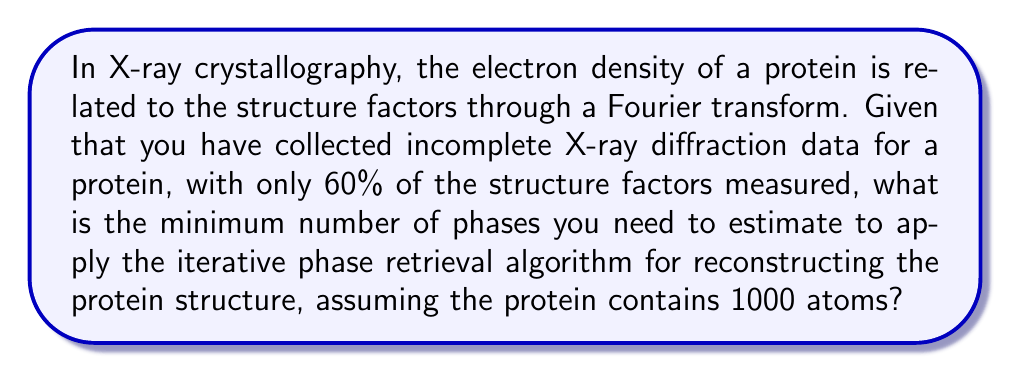Could you help me with this problem? To solve this problem, we need to follow these steps:

1. Understand the relationship between structure factors and electron density:
   The electron density $\rho(x,y,z)$ is related to the structure factors $F(h,k,l)$ through a Fourier transform:

   $$\rho(x,y,z) = \frac{1}{V} \sum_{h,k,l} F(h,k,l) e^{-2\pi i(hx+ky+lz)}$$

   where $V$ is the unit cell volume.

2. Consider the number of structure factors:
   For a protein with $N$ atoms, we typically need approximately $N$ structure factors to describe the electron density adequately.

3. Calculate the number of measured structure factors:
   Given: 1000 atoms in the protein
   Total structure factors needed ≈ 1000
   Measured structure factors = 60% of 1000 = 0.6 × 1000 = 600

4. Determine the number of unknown structure factors:
   Unknown structure factors = Total - Measured = 1000 - 600 = 400

5. Recognize that each structure factor has an amplitude and a phase:
   The measured data typically provides amplitudes, but phases are often unknown.

6. Calculate the minimum number of phases needed:
   To apply the iterative phase retrieval algorithm, we need to estimate at least as many phases as there are unknown structure factors.

   Minimum number of phases to estimate = Number of unknown structure factors = 400
Answer: 400 phases 